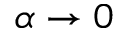<formula> <loc_0><loc_0><loc_500><loc_500>\alpha \to 0</formula> 